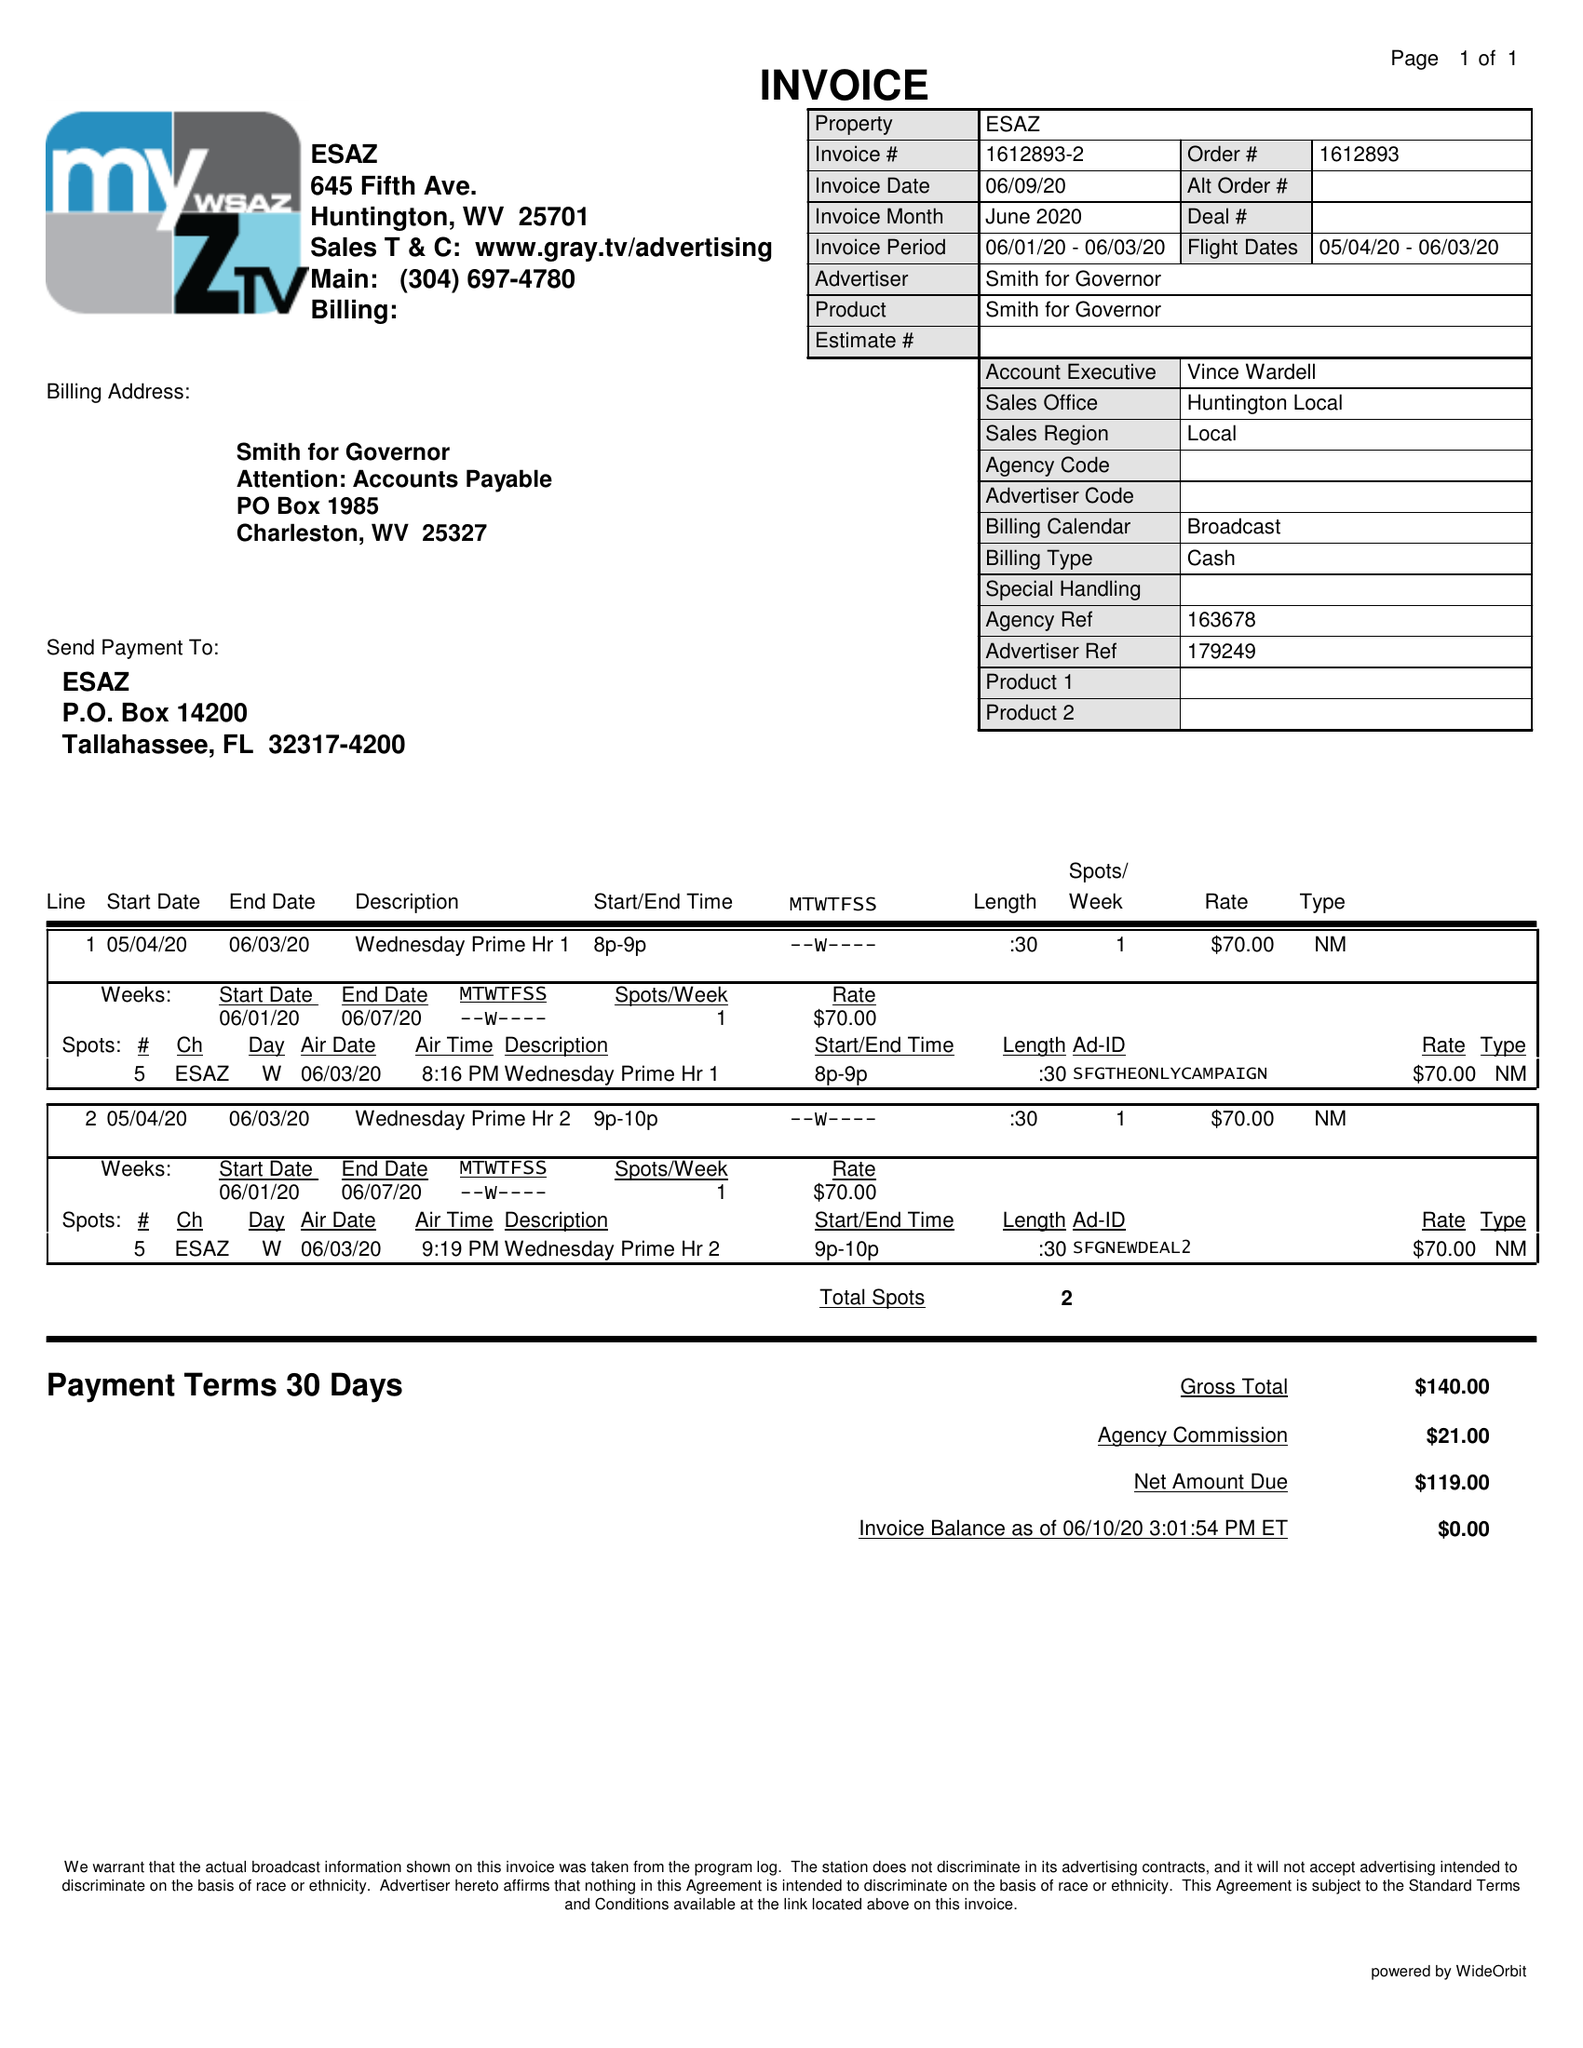What is the value for the advertiser?
Answer the question using a single word or phrase. SMITH FOR GOVERNOR 